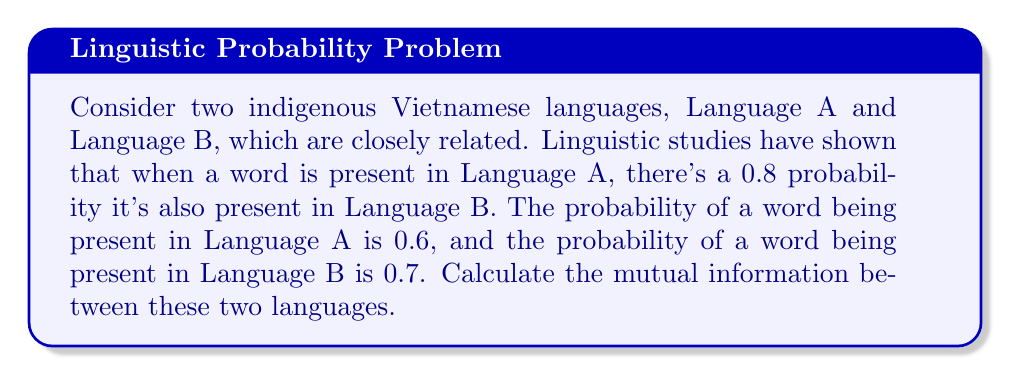Can you solve this math problem? To solve this problem, we need to use the concept of mutual information from information theory. Mutual information quantifies the amount of information obtained about one random variable by observing another random variable.

Let's define our events:
- A: word present in Language A
- B: word present in Language B

Given:
- P(A) = 0.6
- P(B) = 0.7
- P(B|A) = 0.8 (probability of B given A)

Step 1: Calculate P(A,B) using the conditional probability formula:
P(A,B) = P(B|A) * P(A) = 0.8 * 0.6 = 0.48

Step 2: Calculate P(A|B) using Bayes' theorem:
P(A|B) = P(B|A) * P(A) / P(B) = 0.8 * 0.6 / 0.7 ≈ 0.6857

Step 3: Calculate the mutual information using the formula:
$$ I(A;B) = \sum_{a \in A} \sum_{b \in B} P(a,b) \log_2 \frac{P(a,b)}{P(a)P(b)} $$

We need to consider four cases: (A,B), (A,not B), (not A,B), and (not A,not B).

Case (A,B):
P(A,B) = 0.48
P(A)P(B) = 0.6 * 0.7 = 0.42
Contribution = 0.48 * log_2(0.48/0.42) ≈ 0.0416

Case (A,not B):
P(A,not B) = P(A) - P(A,B) = 0.6 - 0.48 = 0.12
P(A)P(not B) = 0.6 * 0.3 = 0.18
Contribution = 0.12 * log_2(0.12/0.18) ≈ -0.0284

Case (not A,B):
P(not A,B) = P(B) - P(A,B) = 0.7 - 0.48 = 0.22
P(not A)P(B) = 0.4 * 0.7 = 0.28
Contribution = 0.22 * log_2(0.22/0.28) ≈ -0.0284

Case (not A,not B):
P(not A,not B) = 1 - P(A) - P(B) + P(A,B) = 1 - 0.6 - 0.7 + 0.48 = 0.18
P(not A)P(not B) = 0.4 * 0.3 = 0.12
Contribution = 0.18 * log_2(0.18/0.12) ≈ 0.0452

Step 4: Sum all contributions:
I(A;B) = 0.0416 - 0.0284 - 0.0284 + 0.0452 ≈ 0.03 bits
Answer: The mutual information between the two indigenous Vietnamese languages is approximately 0.03 bits. 